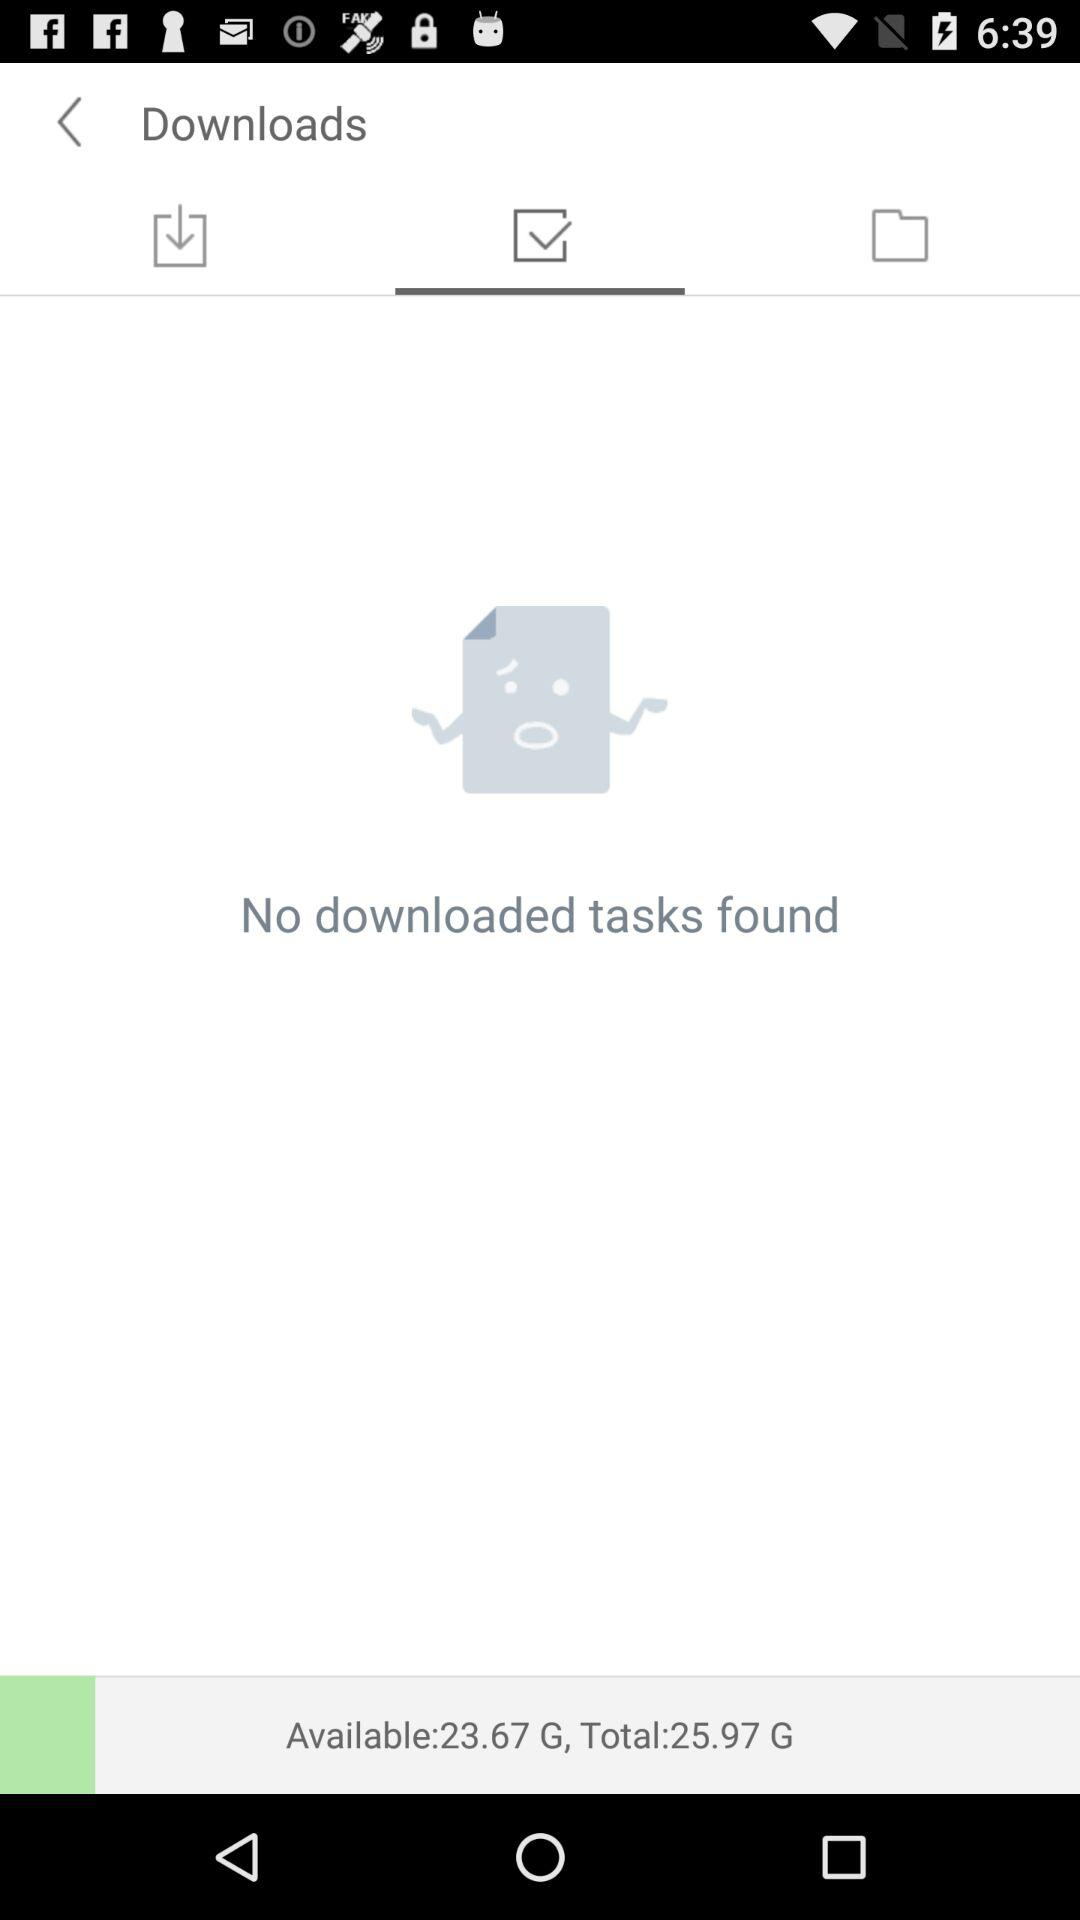How much space is available on the device?
Answer the question using a single word or phrase. 23.67 G 